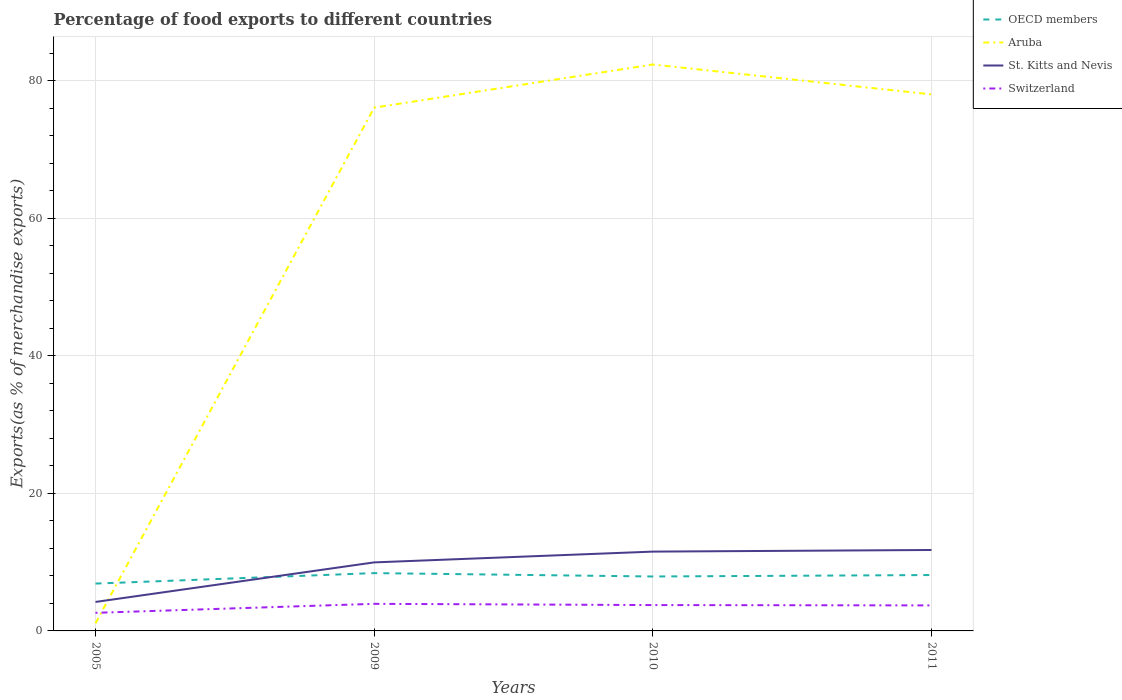How many different coloured lines are there?
Provide a succinct answer. 4. Does the line corresponding to Switzerland intersect with the line corresponding to Aruba?
Offer a terse response. Yes. Is the number of lines equal to the number of legend labels?
Your answer should be compact. Yes. Across all years, what is the maximum percentage of exports to different countries in OECD members?
Provide a succinct answer. 6.88. In which year was the percentage of exports to different countries in Aruba maximum?
Ensure brevity in your answer.  2005. What is the total percentage of exports to different countries in Switzerland in the graph?
Your answer should be very brief. -1.08. What is the difference between the highest and the second highest percentage of exports to different countries in St. Kitts and Nevis?
Your answer should be compact. 7.55. How many lines are there?
Provide a short and direct response. 4. How many years are there in the graph?
Give a very brief answer. 4. Are the values on the major ticks of Y-axis written in scientific E-notation?
Provide a short and direct response. No. Does the graph contain any zero values?
Your answer should be compact. No. Does the graph contain grids?
Your answer should be compact. Yes. Where does the legend appear in the graph?
Provide a succinct answer. Top right. What is the title of the graph?
Keep it short and to the point. Percentage of food exports to different countries. What is the label or title of the Y-axis?
Provide a succinct answer. Exports(as % of merchandise exports). What is the Exports(as % of merchandise exports) of OECD members in 2005?
Offer a terse response. 6.88. What is the Exports(as % of merchandise exports) in Aruba in 2005?
Your answer should be compact. 1.11. What is the Exports(as % of merchandise exports) in St. Kitts and Nevis in 2005?
Make the answer very short. 4.21. What is the Exports(as % of merchandise exports) of Switzerland in 2005?
Provide a succinct answer. 2.63. What is the Exports(as % of merchandise exports) of OECD members in 2009?
Your answer should be compact. 8.4. What is the Exports(as % of merchandise exports) of Aruba in 2009?
Provide a succinct answer. 76.06. What is the Exports(as % of merchandise exports) of St. Kitts and Nevis in 2009?
Your answer should be compact. 9.96. What is the Exports(as % of merchandise exports) in Switzerland in 2009?
Provide a short and direct response. 3.94. What is the Exports(as % of merchandise exports) of OECD members in 2010?
Ensure brevity in your answer.  7.91. What is the Exports(as % of merchandise exports) of Aruba in 2010?
Keep it short and to the point. 82.33. What is the Exports(as % of merchandise exports) in St. Kitts and Nevis in 2010?
Your answer should be compact. 11.53. What is the Exports(as % of merchandise exports) in Switzerland in 2010?
Your response must be concise. 3.76. What is the Exports(as % of merchandise exports) of OECD members in 2011?
Your response must be concise. 8.12. What is the Exports(as % of merchandise exports) in Aruba in 2011?
Your answer should be compact. 77.98. What is the Exports(as % of merchandise exports) of St. Kitts and Nevis in 2011?
Ensure brevity in your answer.  11.76. What is the Exports(as % of merchandise exports) of Switzerland in 2011?
Give a very brief answer. 3.71. Across all years, what is the maximum Exports(as % of merchandise exports) of OECD members?
Make the answer very short. 8.4. Across all years, what is the maximum Exports(as % of merchandise exports) of Aruba?
Provide a short and direct response. 82.33. Across all years, what is the maximum Exports(as % of merchandise exports) in St. Kitts and Nevis?
Offer a very short reply. 11.76. Across all years, what is the maximum Exports(as % of merchandise exports) in Switzerland?
Your answer should be very brief. 3.94. Across all years, what is the minimum Exports(as % of merchandise exports) in OECD members?
Provide a succinct answer. 6.88. Across all years, what is the minimum Exports(as % of merchandise exports) of Aruba?
Provide a short and direct response. 1.11. Across all years, what is the minimum Exports(as % of merchandise exports) in St. Kitts and Nevis?
Make the answer very short. 4.21. Across all years, what is the minimum Exports(as % of merchandise exports) of Switzerland?
Offer a terse response. 2.63. What is the total Exports(as % of merchandise exports) of OECD members in the graph?
Provide a succinct answer. 31.32. What is the total Exports(as % of merchandise exports) of Aruba in the graph?
Ensure brevity in your answer.  237.48. What is the total Exports(as % of merchandise exports) of St. Kitts and Nevis in the graph?
Give a very brief answer. 37.47. What is the total Exports(as % of merchandise exports) of Switzerland in the graph?
Offer a terse response. 14.03. What is the difference between the Exports(as % of merchandise exports) in OECD members in 2005 and that in 2009?
Ensure brevity in your answer.  -1.52. What is the difference between the Exports(as % of merchandise exports) in Aruba in 2005 and that in 2009?
Provide a short and direct response. -74.96. What is the difference between the Exports(as % of merchandise exports) in St. Kitts and Nevis in 2005 and that in 2009?
Make the answer very short. -5.75. What is the difference between the Exports(as % of merchandise exports) in Switzerland in 2005 and that in 2009?
Your response must be concise. -1.31. What is the difference between the Exports(as % of merchandise exports) of OECD members in 2005 and that in 2010?
Your answer should be compact. -1.03. What is the difference between the Exports(as % of merchandise exports) in Aruba in 2005 and that in 2010?
Your response must be concise. -81.22. What is the difference between the Exports(as % of merchandise exports) in St. Kitts and Nevis in 2005 and that in 2010?
Give a very brief answer. -7.32. What is the difference between the Exports(as % of merchandise exports) of Switzerland in 2005 and that in 2010?
Offer a very short reply. -1.13. What is the difference between the Exports(as % of merchandise exports) of OECD members in 2005 and that in 2011?
Keep it short and to the point. -1.24. What is the difference between the Exports(as % of merchandise exports) in Aruba in 2005 and that in 2011?
Make the answer very short. -76.88. What is the difference between the Exports(as % of merchandise exports) of St. Kitts and Nevis in 2005 and that in 2011?
Give a very brief answer. -7.55. What is the difference between the Exports(as % of merchandise exports) in Switzerland in 2005 and that in 2011?
Your answer should be very brief. -1.08. What is the difference between the Exports(as % of merchandise exports) in OECD members in 2009 and that in 2010?
Provide a succinct answer. 0.49. What is the difference between the Exports(as % of merchandise exports) of Aruba in 2009 and that in 2010?
Offer a very short reply. -6.26. What is the difference between the Exports(as % of merchandise exports) of St. Kitts and Nevis in 2009 and that in 2010?
Provide a short and direct response. -1.57. What is the difference between the Exports(as % of merchandise exports) in Switzerland in 2009 and that in 2010?
Offer a terse response. 0.18. What is the difference between the Exports(as % of merchandise exports) of OECD members in 2009 and that in 2011?
Your answer should be very brief. 0.28. What is the difference between the Exports(as % of merchandise exports) in Aruba in 2009 and that in 2011?
Make the answer very short. -1.92. What is the difference between the Exports(as % of merchandise exports) of St. Kitts and Nevis in 2009 and that in 2011?
Your response must be concise. -1.8. What is the difference between the Exports(as % of merchandise exports) in Switzerland in 2009 and that in 2011?
Offer a terse response. 0.23. What is the difference between the Exports(as % of merchandise exports) of OECD members in 2010 and that in 2011?
Keep it short and to the point. -0.21. What is the difference between the Exports(as % of merchandise exports) of Aruba in 2010 and that in 2011?
Offer a terse response. 4.34. What is the difference between the Exports(as % of merchandise exports) of St. Kitts and Nevis in 2010 and that in 2011?
Provide a short and direct response. -0.24. What is the difference between the Exports(as % of merchandise exports) of Switzerland in 2010 and that in 2011?
Your response must be concise. 0.05. What is the difference between the Exports(as % of merchandise exports) in OECD members in 2005 and the Exports(as % of merchandise exports) in Aruba in 2009?
Offer a terse response. -69.18. What is the difference between the Exports(as % of merchandise exports) of OECD members in 2005 and the Exports(as % of merchandise exports) of St. Kitts and Nevis in 2009?
Offer a terse response. -3.08. What is the difference between the Exports(as % of merchandise exports) in OECD members in 2005 and the Exports(as % of merchandise exports) in Switzerland in 2009?
Your answer should be compact. 2.94. What is the difference between the Exports(as % of merchandise exports) of Aruba in 2005 and the Exports(as % of merchandise exports) of St. Kitts and Nevis in 2009?
Ensure brevity in your answer.  -8.86. What is the difference between the Exports(as % of merchandise exports) of Aruba in 2005 and the Exports(as % of merchandise exports) of Switzerland in 2009?
Keep it short and to the point. -2.83. What is the difference between the Exports(as % of merchandise exports) of St. Kitts and Nevis in 2005 and the Exports(as % of merchandise exports) of Switzerland in 2009?
Offer a very short reply. 0.27. What is the difference between the Exports(as % of merchandise exports) of OECD members in 2005 and the Exports(as % of merchandise exports) of Aruba in 2010?
Provide a succinct answer. -75.45. What is the difference between the Exports(as % of merchandise exports) of OECD members in 2005 and the Exports(as % of merchandise exports) of St. Kitts and Nevis in 2010?
Your answer should be compact. -4.65. What is the difference between the Exports(as % of merchandise exports) of OECD members in 2005 and the Exports(as % of merchandise exports) of Switzerland in 2010?
Provide a short and direct response. 3.12. What is the difference between the Exports(as % of merchandise exports) in Aruba in 2005 and the Exports(as % of merchandise exports) in St. Kitts and Nevis in 2010?
Your answer should be very brief. -10.42. What is the difference between the Exports(as % of merchandise exports) in Aruba in 2005 and the Exports(as % of merchandise exports) in Switzerland in 2010?
Offer a very short reply. -2.65. What is the difference between the Exports(as % of merchandise exports) of St. Kitts and Nevis in 2005 and the Exports(as % of merchandise exports) of Switzerland in 2010?
Give a very brief answer. 0.45. What is the difference between the Exports(as % of merchandise exports) in OECD members in 2005 and the Exports(as % of merchandise exports) in Aruba in 2011?
Give a very brief answer. -71.1. What is the difference between the Exports(as % of merchandise exports) in OECD members in 2005 and the Exports(as % of merchandise exports) in St. Kitts and Nevis in 2011?
Keep it short and to the point. -4.88. What is the difference between the Exports(as % of merchandise exports) in OECD members in 2005 and the Exports(as % of merchandise exports) in Switzerland in 2011?
Ensure brevity in your answer.  3.17. What is the difference between the Exports(as % of merchandise exports) of Aruba in 2005 and the Exports(as % of merchandise exports) of St. Kitts and Nevis in 2011?
Offer a terse response. -10.66. What is the difference between the Exports(as % of merchandise exports) of Aruba in 2005 and the Exports(as % of merchandise exports) of Switzerland in 2011?
Provide a succinct answer. -2.6. What is the difference between the Exports(as % of merchandise exports) in St. Kitts and Nevis in 2005 and the Exports(as % of merchandise exports) in Switzerland in 2011?
Give a very brief answer. 0.5. What is the difference between the Exports(as % of merchandise exports) of OECD members in 2009 and the Exports(as % of merchandise exports) of Aruba in 2010?
Ensure brevity in your answer.  -73.93. What is the difference between the Exports(as % of merchandise exports) of OECD members in 2009 and the Exports(as % of merchandise exports) of St. Kitts and Nevis in 2010?
Provide a succinct answer. -3.12. What is the difference between the Exports(as % of merchandise exports) of OECD members in 2009 and the Exports(as % of merchandise exports) of Switzerland in 2010?
Your answer should be very brief. 4.64. What is the difference between the Exports(as % of merchandise exports) in Aruba in 2009 and the Exports(as % of merchandise exports) in St. Kitts and Nevis in 2010?
Your answer should be compact. 64.54. What is the difference between the Exports(as % of merchandise exports) of Aruba in 2009 and the Exports(as % of merchandise exports) of Switzerland in 2010?
Provide a succinct answer. 72.31. What is the difference between the Exports(as % of merchandise exports) of St. Kitts and Nevis in 2009 and the Exports(as % of merchandise exports) of Switzerland in 2010?
Make the answer very short. 6.2. What is the difference between the Exports(as % of merchandise exports) in OECD members in 2009 and the Exports(as % of merchandise exports) in Aruba in 2011?
Offer a very short reply. -69.58. What is the difference between the Exports(as % of merchandise exports) in OECD members in 2009 and the Exports(as % of merchandise exports) in St. Kitts and Nevis in 2011?
Provide a succinct answer. -3.36. What is the difference between the Exports(as % of merchandise exports) in OECD members in 2009 and the Exports(as % of merchandise exports) in Switzerland in 2011?
Keep it short and to the point. 4.69. What is the difference between the Exports(as % of merchandise exports) of Aruba in 2009 and the Exports(as % of merchandise exports) of St. Kitts and Nevis in 2011?
Ensure brevity in your answer.  64.3. What is the difference between the Exports(as % of merchandise exports) of Aruba in 2009 and the Exports(as % of merchandise exports) of Switzerland in 2011?
Ensure brevity in your answer.  72.36. What is the difference between the Exports(as % of merchandise exports) of St. Kitts and Nevis in 2009 and the Exports(as % of merchandise exports) of Switzerland in 2011?
Make the answer very short. 6.25. What is the difference between the Exports(as % of merchandise exports) of OECD members in 2010 and the Exports(as % of merchandise exports) of Aruba in 2011?
Give a very brief answer. -70.07. What is the difference between the Exports(as % of merchandise exports) of OECD members in 2010 and the Exports(as % of merchandise exports) of St. Kitts and Nevis in 2011?
Ensure brevity in your answer.  -3.85. What is the difference between the Exports(as % of merchandise exports) of OECD members in 2010 and the Exports(as % of merchandise exports) of Switzerland in 2011?
Ensure brevity in your answer.  4.2. What is the difference between the Exports(as % of merchandise exports) in Aruba in 2010 and the Exports(as % of merchandise exports) in St. Kitts and Nevis in 2011?
Ensure brevity in your answer.  70.56. What is the difference between the Exports(as % of merchandise exports) in Aruba in 2010 and the Exports(as % of merchandise exports) in Switzerland in 2011?
Provide a short and direct response. 78.62. What is the difference between the Exports(as % of merchandise exports) in St. Kitts and Nevis in 2010 and the Exports(as % of merchandise exports) in Switzerland in 2011?
Your response must be concise. 7.82. What is the average Exports(as % of merchandise exports) in OECD members per year?
Your response must be concise. 7.83. What is the average Exports(as % of merchandise exports) of Aruba per year?
Your response must be concise. 59.37. What is the average Exports(as % of merchandise exports) of St. Kitts and Nevis per year?
Ensure brevity in your answer.  9.37. What is the average Exports(as % of merchandise exports) in Switzerland per year?
Your answer should be very brief. 3.51. In the year 2005, what is the difference between the Exports(as % of merchandise exports) in OECD members and Exports(as % of merchandise exports) in Aruba?
Your answer should be very brief. 5.77. In the year 2005, what is the difference between the Exports(as % of merchandise exports) of OECD members and Exports(as % of merchandise exports) of St. Kitts and Nevis?
Your answer should be compact. 2.67. In the year 2005, what is the difference between the Exports(as % of merchandise exports) of OECD members and Exports(as % of merchandise exports) of Switzerland?
Provide a short and direct response. 4.25. In the year 2005, what is the difference between the Exports(as % of merchandise exports) in Aruba and Exports(as % of merchandise exports) in St. Kitts and Nevis?
Give a very brief answer. -3.11. In the year 2005, what is the difference between the Exports(as % of merchandise exports) in Aruba and Exports(as % of merchandise exports) in Switzerland?
Offer a terse response. -1.52. In the year 2005, what is the difference between the Exports(as % of merchandise exports) in St. Kitts and Nevis and Exports(as % of merchandise exports) in Switzerland?
Offer a very short reply. 1.58. In the year 2009, what is the difference between the Exports(as % of merchandise exports) in OECD members and Exports(as % of merchandise exports) in Aruba?
Make the answer very short. -67.66. In the year 2009, what is the difference between the Exports(as % of merchandise exports) of OECD members and Exports(as % of merchandise exports) of St. Kitts and Nevis?
Make the answer very short. -1.56. In the year 2009, what is the difference between the Exports(as % of merchandise exports) of OECD members and Exports(as % of merchandise exports) of Switzerland?
Keep it short and to the point. 4.47. In the year 2009, what is the difference between the Exports(as % of merchandise exports) of Aruba and Exports(as % of merchandise exports) of St. Kitts and Nevis?
Make the answer very short. 66.1. In the year 2009, what is the difference between the Exports(as % of merchandise exports) in Aruba and Exports(as % of merchandise exports) in Switzerland?
Keep it short and to the point. 72.13. In the year 2009, what is the difference between the Exports(as % of merchandise exports) in St. Kitts and Nevis and Exports(as % of merchandise exports) in Switzerland?
Provide a short and direct response. 6.02. In the year 2010, what is the difference between the Exports(as % of merchandise exports) in OECD members and Exports(as % of merchandise exports) in Aruba?
Provide a succinct answer. -74.42. In the year 2010, what is the difference between the Exports(as % of merchandise exports) of OECD members and Exports(as % of merchandise exports) of St. Kitts and Nevis?
Provide a short and direct response. -3.62. In the year 2010, what is the difference between the Exports(as % of merchandise exports) in OECD members and Exports(as % of merchandise exports) in Switzerland?
Your answer should be compact. 4.15. In the year 2010, what is the difference between the Exports(as % of merchandise exports) in Aruba and Exports(as % of merchandise exports) in St. Kitts and Nevis?
Make the answer very short. 70.8. In the year 2010, what is the difference between the Exports(as % of merchandise exports) of Aruba and Exports(as % of merchandise exports) of Switzerland?
Provide a short and direct response. 78.57. In the year 2010, what is the difference between the Exports(as % of merchandise exports) of St. Kitts and Nevis and Exports(as % of merchandise exports) of Switzerland?
Your answer should be very brief. 7.77. In the year 2011, what is the difference between the Exports(as % of merchandise exports) of OECD members and Exports(as % of merchandise exports) of Aruba?
Give a very brief answer. -69.86. In the year 2011, what is the difference between the Exports(as % of merchandise exports) of OECD members and Exports(as % of merchandise exports) of St. Kitts and Nevis?
Keep it short and to the point. -3.64. In the year 2011, what is the difference between the Exports(as % of merchandise exports) in OECD members and Exports(as % of merchandise exports) in Switzerland?
Your response must be concise. 4.41. In the year 2011, what is the difference between the Exports(as % of merchandise exports) in Aruba and Exports(as % of merchandise exports) in St. Kitts and Nevis?
Give a very brief answer. 66.22. In the year 2011, what is the difference between the Exports(as % of merchandise exports) of Aruba and Exports(as % of merchandise exports) of Switzerland?
Give a very brief answer. 74.28. In the year 2011, what is the difference between the Exports(as % of merchandise exports) of St. Kitts and Nevis and Exports(as % of merchandise exports) of Switzerland?
Make the answer very short. 8.06. What is the ratio of the Exports(as % of merchandise exports) in OECD members in 2005 to that in 2009?
Offer a terse response. 0.82. What is the ratio of the Exports(as % of merchandise exports) in Aruba in 2005 to that in 2009?
Your answer should be very brief. 0.01. What is the ratio of the Exports(as % of merchandise exports) in St. Kitts and Nevis in 2005 to that in 2009?
Keep it short and to the point. 0.42. What is the ratio of the Exports(as % of merchandise exports) in Switzerland in 2005 to that in 2009?
Offer a terse response. 0.67. What is the ratio of the Exports(as % of merchandise exports) in OECD members in 2005 to that in 2010?
Provide a short and direct response. 0.87. What is the ratio of the Exports(as % of merchandise exports) in Aruba in 2005 to that in 2010?
Give a very brief answer. 0.01. What is the ratio of the Exports(as % of merchandise exports) of St. Kitts and Nevis in 2005 to that in 2010?
Ensure brevity in your answer.  0.37. What is the ratio of the Exports(as % of merchandise exports) of Switzerland in 2005 to that in 2010?
Make the answer very short. 0.7. What is the ratio of the Exports(as % of merchandise exports) of OECD members in 2005 to that in 2011?
Your response must be concise. 0.85. What is the ratio of the Exports(as % of merchandise exports) of Aruba in 2005 to that in 2011?
Ensure brevity in your answer.  0.01. What is the ratio of the Exports(as % of merchandise exports) of St. Kitts and Nevis in 2005 to that in 2011?
Offer a terse response. 0.36. What is the ratio of the Exports(as % of merchandise exports) of Switzerland in 2005 to that in 2011?
Your answer should be compact. 0.71. What is the ratio of the Exports(as % of merchandise exports) in OECD members in 2009 to that in 2010?
Your answer should be compact. 1.06. What is the ratio of the Exports(as % of merchandise exports) in Aruba in 2009 to that in 2010?
Your response must be concise. 0.92. What is the ratio of the Exports(as % of merchandise exports) in St. Kitts and Nevis in 2009 to that in 2010?
Provide a short and direct response. 0.86. What is the ratio of the Exports(as % of merchandise exports) in Switzerland in 2009 to that in 2010?
Give a very brief answer. 1.05. What is the ratio of the Exports(as % of merchandise exports) in OECD members in 2009 to that in 2011?
Provide a short and direct response. 1.03. What is the ratio of the Exports(as % of merchandise exports) of Aruba in 2009 to that in 2011?
Ensure brevity in your answer.  0.98. What is the ratio of the Exports(as % of merchandise exports) in St. Kitts and Nevis in 2009 to that in 2011?
Your response must be concise. 0.85. What is the ratio of the Exports(as % of merchandise exports) of Switzerland in 2009 to that in 2011?
Provide a succinct answer. 1.06. What is the ratio of the Exports(as % of merchandise exports) in OECD members in 2010 to that in 2011?
Your answer should be very brief. 0.97. What is the ratio of the Exports(as % of merchandise exports) of Aruba in 2010 to that in 2011?
Give a very brief answer. 1.06. What is the ratio of the Exports(as % of merchandise exports) in St. Kitts and Nevis in 2010 to that in 2011?
Provide a succinct answer. 0.98. What is the ratio of the Exports(as % of merchandise exports) in Switzerland in 2010 to that in 2011?
Ensure brevity in your answer.  1.01. What is the difference between the highest and the second highest Exports(as % of merchandise exports) of OECD members?
Offer a very short reply. 0.28. What is the difference between the highest and the second highest Exports(as % of merchandise exports) of Aruba?
Provide a succinct answer. 4.34. What is the difference between the highest and the second highest Exports(as % of merchandise exports) in St. Kitts and Nevis?
Offer a very short reply. 0.24. What is the difference between the highest and the second highest Exports(as % of merchandise exports) of Switzerland?
Provide a short and direct response. 0.18. What is the difference between the highest and the lowest Exports(as % of merchandise exports) in OECD members?
Give a very brief answer. 1.52. What is the difference between the highest and the lowest Exports(as % of merchandise exports) of Aruba?
Your answer should be compact. 81.22. What is the difference between the highest and the lowest Exports(as % of merchandise exports) of St. Kitts and Nevis?
Give a very brief answer. 7.55. What is the difference between the highest and the lowest Exports(as % of merchandise exports) in Switzerland?
Your answer should be very brief. 1.31. 